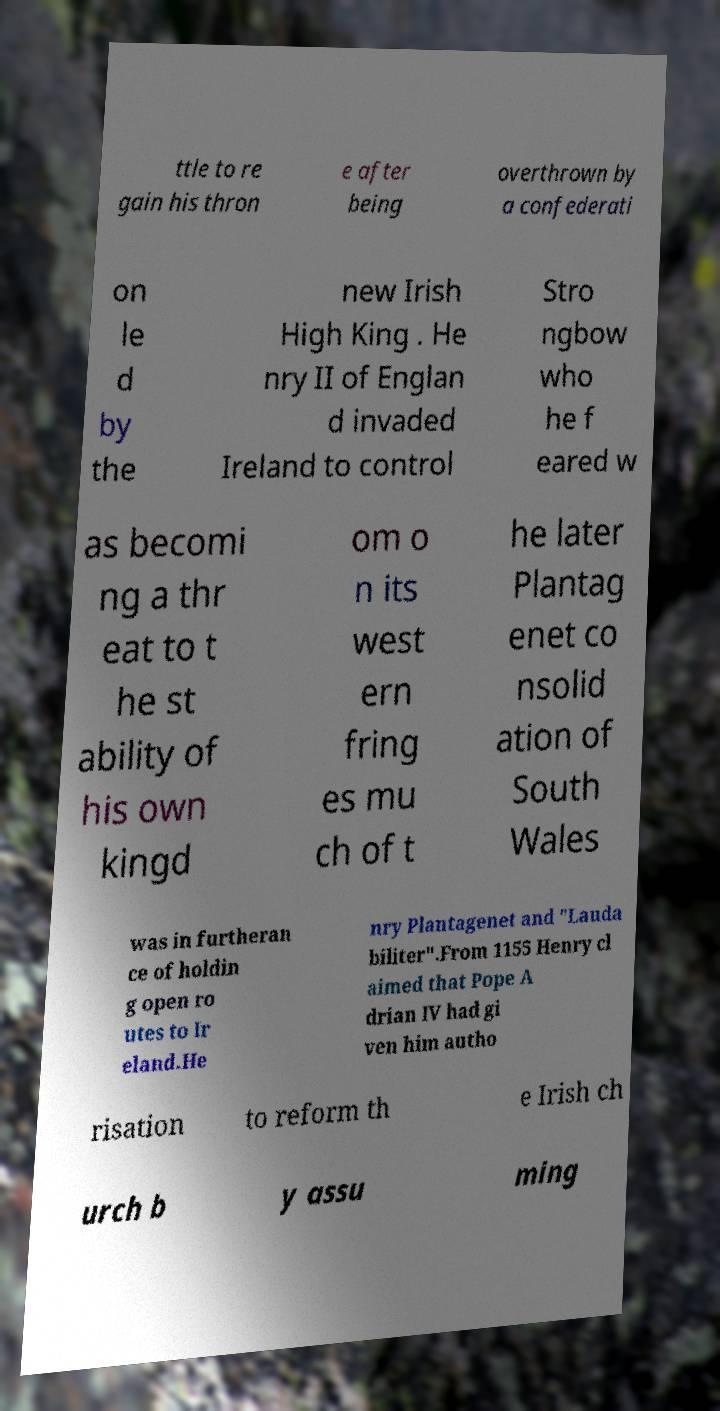Can you accurately transcribe the text from the provided image for me? ttle to re gain his thron e after being overthrown by a confederati on le d by the new Irish High King . He nry II of Englan d invaded Ireland to control Stro ngbow who he f eared w as becomi ng a thr eat to t he st ability of his own kingd om o n its west ern fring es mu ch of t he later Plantag enet co nsolid ation of South Wales was in furtheran ce of holdin g open ro utes to Ir eland.He nry Plantagenet and "Lauda biliter".From 1155 Henry cl aimed that Pope A drian IV had gi ven him autho risation to reform th e Irish ch urch b y assu ming 